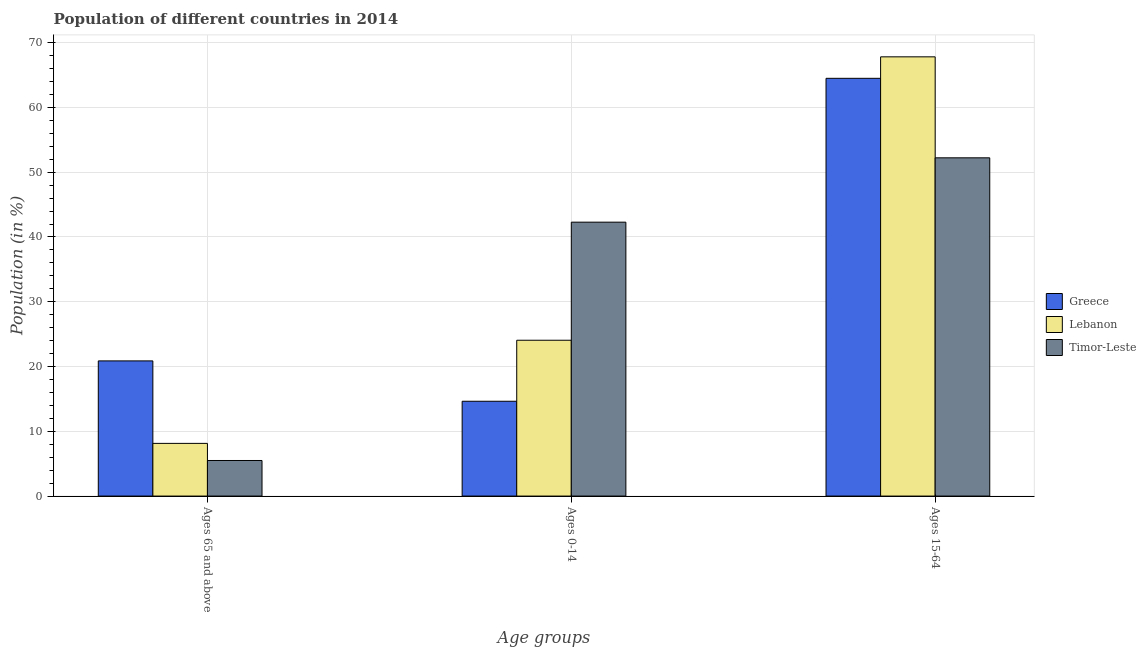How many groups of bars are there?
Provide a succinct answer. 3. Are the number of bars per tick equal to the number of legend labels?
Your answer should be very brief. Yes. Are the number of bars on each tick of the X-axis equal?
Your answer should be very brief. Yes. What is the label of the 1st group of bars from the left?
Offer a terse response. Ages 65 and above. What is the percentage of population within the age-group 0-14 in Lebanon?
Provide a short and direct response. 24.06. Across all countries, what is the maximum percentage of population within the age-group 15-64?
Ensure brevity in your answer.  67.81. Across all countries, what is the minimum percentage of population within the age-group 15-64?
Your answer should be very brief. 52.22. In which country was the percentage of population within the age-group 0-14 maximum?
Keep it short and to the point. Timor-Leste. In which country was the percentage of population within the age-group of 65 and above minimum?
Make the answer very short. Timor-Leste. What is the total percentage of population within the age-group 0-14 in the graph?
Keep it short and to the point. 80.98. What is the difference between the percentage of population within the age-group 15-64 in Timor-Leste and that in Greece?
Provide a succinct answer. -12.27. What is the difference between the percentage of population within the age-group 15-64 in Greece and the percentage of population within the age-group 0-14 in Timor-Leste?
Your answer should be very brief. 22.21. What is the average percentage of population within the age-group of 65 and above per country?
Your answer should be compact. 11.5. What is the difference between the percentage of population within the age-group 15-64 and percentage of population within the age-group of 65 and above in Greece?
Your answer should be compact. 43.62. In how many countries, is the percentage of population within the age-group of 65 and above greater than 52 %?
Provide a short and direct response. 0. What is the ratio of the percentage of population within the age-group 15-64 in Lebanon to that in Greece?
Your answer should be very brief. 1.05. Is the percentage of population within the age-group of 65 and above in Lebanon less than that in Greece?
Keep it short and to the point. Yes. What is the difference between the highest and the second highest percentage of population within the age-group of 65 and above?
Provide a succinct answer. 12.74. What is the difference between the highest and the lowest percentage of population within the age-group 15-64?
Your answer should be compact. 15.59. Is the sum of the percentage of population within the age-group 0-14 in Greece and Timor-Leste greater than the maximum percentage of population within the age-group of 65 and above across all countries?
Give a very brief answer. Yes. What does the 2nd bar from the left in Ages 15-64 represents?
Your answer should be compact. Lebanon. What does the 3rd bar from the right in Ages 15-64 represents?
Provide a short and direct response. Greece. How many bars are there?
Provide a short and direct response. 9. Are all the bars in the graph horizontal?
Ensure brevity in your answer.  No. How many countries are there in the graph?
Your answer should be compact. 3. Are the values on the major ticks of Y-axis written in scientific E-notation?
Provide a succinct answer. No. Does the graph contain grids?
Offer a terse response. Yes. Where does the legend appear in the graph?
Your response must be concise. Center right. How many legend labels are there?
Your answer should be very brief. 3. How are the legend labels stacked?
Give a very brief answer. Vertical. What is the title of the graph?
Offer a terse response. Population of different countries in 2014. Does "Eritrea" appear as one of the legend labels in the graph?
Offer a terse response. No. What is the label or title of the X-axis?
Your answer should be very brief. Age groups. What is the label or title of the Y-axis?
Provide a succinct answer. Population (in %). What is the Population (in %) of Greece in Ages 65 and above?
Your answer should be very brief. 20.87. What is the Population (in %) of Lebanon in Ages 65 and above?
Provide a short and direct response. 8.13. What is the Population (in %) in Timor-Leste in Ages 65 and above?
Your answer should be very brief. 5.49. What is the Population (in %) in Greece in Ages 0-14?
Provide a succinct answer. 14.64. What is the Population (in %) of Lebanon in Ages 0-14?
Offer a terse response. 24.06. What is the Population (in %) of Timor-Leste in Ages 0-14?
Your answer should be very brief. 42.29. What is the Population (in %) in Greece in Ages 15-64?
Keep it short and to the point. 64.49. What is the Population (in %) in Lebanon in Ages 15-64?
Your response must be concise. 67.81. What is the Population (in %) of Timor-Leste in Ages 15-64?
Offer a very short reply. 52.22. Across all Age groups, what is the maximum Population (in %) of Greece?
Offer a very short reply. 64.49. Across all Age groups, what is the maximum Population (in %) in Lebanon?
Offer a terse response. 67.81. Across all Age groups, what is the maximum Population (in %) in Timor-Leste?
Ensure brevity in your answer.  52.22. Across all Age groups, what is the minimum Population (in %) of Greece?
Your answer should be very brief. 14.64. Across all Age groups, what is the minimum Population (in %) in Lebanon?
Your answer should be very brief. 8.13. Across all Age groups, what is the minimum Population (in %) in Timor-Leste?
Your answer should be very brief. 5.49. What is the total Population (in %) in Greece in the graph?
Give a very brief answer. 100. What is the total Population (in %) in Lebanon in the graph?
Offer a very short reply. 100. What is the difference between the Population (in %) of Greece in Ages 65 and above and that in Ages 0-14?
Your response must be concise. 6.23. What is the difference between the Population (in %) of Lebanon in Ages 65 and above and that in Ages 0-14?
Offer a very short reply. -15.92. What is the difference between the Population (in %) in Timor-Leste in Ages 65 and above and that in Ages 0-14?
Your answer should be compact. -36.8. What is the difference between the Population (in %) in Greece in Ages 65 and above and that in Ages 15-64?
Offer a very short reply. -43.62. What is the difference between the Population (in %) of Lebanon in Ages 65 and above and that in Ages 15-64?
Your answer should be compact. -59.68. What is the difference between the Population (in %) in Timor-Leste in Ages 65 and above and that in Ages 15-64?
Your answer should be compact. -46.73. What is the difference between the Population (in %) in Greece in Ages 0-14 and that in Ages 15-64?
Your answer should be compact. -49.85. What is the difference between the Population (in %) of Lebanon in Ages 0-14 and that in Ages 15-64?
Offer a terse response. -43.75. What is the difference between the Population (in %) in Timor-Leste in Ages 0-14 and that in Ages 15-64?
Make the answer very short. -9.93. What is the difference between the Population (in %) of Greece in Ages 65 and above and the Population (in %) of Lebanon in Ages 0-14?
Your answer should be compact. -3.19. What is the difference between the Population (in %) of Greece in Ages 65 and above and the Population (in %) of Timor-Leste in Ages 0-14?
Keep it short and to the point. -21.42. What is the difference between the Population (in %) in Lebanon in Ages 65 and above and the Population (in %) in Timor-Leste in Ages 0-14?
Your response must be concise. -34.15. What is the difference between the Population (in %) of Greece in Ages 65 and above and the Population (in %) of Lebanon in Ages 15-64?
Provide a short and direct response. -46.94. What is the difference between the Population (in %) of Greece in Ages 65 and above and the Population (in %) of Timor-Leste in Ages 15-64?
Your response must be concise. -31.35. What is the difference between the Population (in %) in Lebanon in Ages 65 and above and the Population (in %) in Timor-Leste in Ages 15-64?
Provide a short and direct response. -44.09. What is the difference between the Population (in %) of Greece in Ages 0-14 and the Population (in %) of Lebanon in Ages 15-64?
Offer a very short reply. -53.17. What is the difference between the Population (in %) in Greece in Ages 0-14 and the Population (in %) in Timor-Leste in Ages 15-64?
Your response must be concise. -37.58. What is the difference between the Population (in %) of Lebanon in Ages 0-14 and the Population (in %) of Timor-Leste in Ages 15-64?
Make the answer very short. -28.16. What is the average Population (in %) of Greece per Age groups?
Your answer should be very brief. 33.33. What is the average Population (in %) of Lebanon per Age groups?
Keep it short and to the point. 33.33. What is the average Population (in %) in Timor-Leste per Age groups?
Your answer should be compact. 33.33. What is the difference between the Population (in %) in Greece and Population (in %) in Lebanon in Ages 65 and above?
Provide a succinct answer. 12.74. What is the difference between the Population (in %) in Greece and Population (in %) in Timor-Leste in Ages 65 and above?
Provide a succinct answer. 15.38. What is the difference between the Population (in %) of Lebanon and Population (in %) of Timor-Leste in Ages 65 and above?
Your response must be concise. 2.64. What is the difference between the Population (in %) in Greece and Population (in %) in Lebanon in Ages 0-14?
Make the answer very short. -9.42. What is the difference between the Population (in %) in Greece and Population (in %) in Timor-Leste in Ages 0-14?
Offer a very short reply. -27.65. What is the difference between the Population (in %) of Lebanon and Population (in %) of Timor-Leste in Ages 0-14?
Make the answer very short. -18.23. What is the difference between the Population (in %) of Greece and Population (in %) of Lebanon in Ages 15-64?
Offer a terse response. -3.32. What is the difference between the Population (in %) of Greece and Population (in %) of Timor-Leste in Ages 15-64?
Provide a succinct answer. 12.27. What is the difference between the Population (in %) in Lebanon and Population (in %) in Timor-Leste in Ages 15-64?
Provide a short and direct response. 15.59. What is the ratio of the Population (in %) of Greece in Ages 65 and above to that in Ages 0-14?
Ensure brevity in your answer.  1.43. What is the ratio of the Population (in %) in Lebanon in Ages 65 and above to that in Ages 0-14?
Your answer should be very brief. 0.34. What is the ratio of the Population (in %) in Timor-Leste in Ages 65 and above to that in Ages 0-14?
Your answer should be compact. 0.13. What is the ratio of the Population (in %) in Greece in Ages 65 and above to that in Ages 15-64?
Provide a short and direct response. 0.32. What is the ratio of the Population (in %) of Lebanon in Ages 65 and above to that in Ages 15-64?
Provide a short and direct response. 0.12. What is the ratio of the Population (in %) in Timor-Leste in Ages 65 and above to that in Ages 15-64?
Keep it short and to the point. 0.11. What is the ratio of the Population (in %) of Greece in Ages 0-14 to that in Ages 15-64?
Ensure brevity in your answer.  0.23. What is the ratio of the Population (in %) of Lebanon in Ages 0-14 to that in Ages 15-64?
Offer a terse response. 0.35. What is the ratio of the Population (in %) in Timor-Leste in Ages 0-14 to that in Ages 15-64?
Your answer should be compact. 0.81. What is the difference between the highest and the second highest Population (in %) in Greece?
Make the answer very short. 43.62. What is the difference between the highest and the second highest Population (in %) of Lebanon?
Your answer should be very brief. 43.75. What is the difference between the highest and the second highest Population (in %) in Timor-Leste?
Offer a terse response. 9.93. What is the difference between the highest and the lowest Population (in %) of Greece?
Your answer should be compact. 49.85. What is the difference between the highest and the lowest Population (in %) in Lebanon?
Ensure brevity in your answer.  59.68. What is the difference between the highest and the lowest Population (in %) in Timor-Leste?
Give a very brief answer. 46.73. 